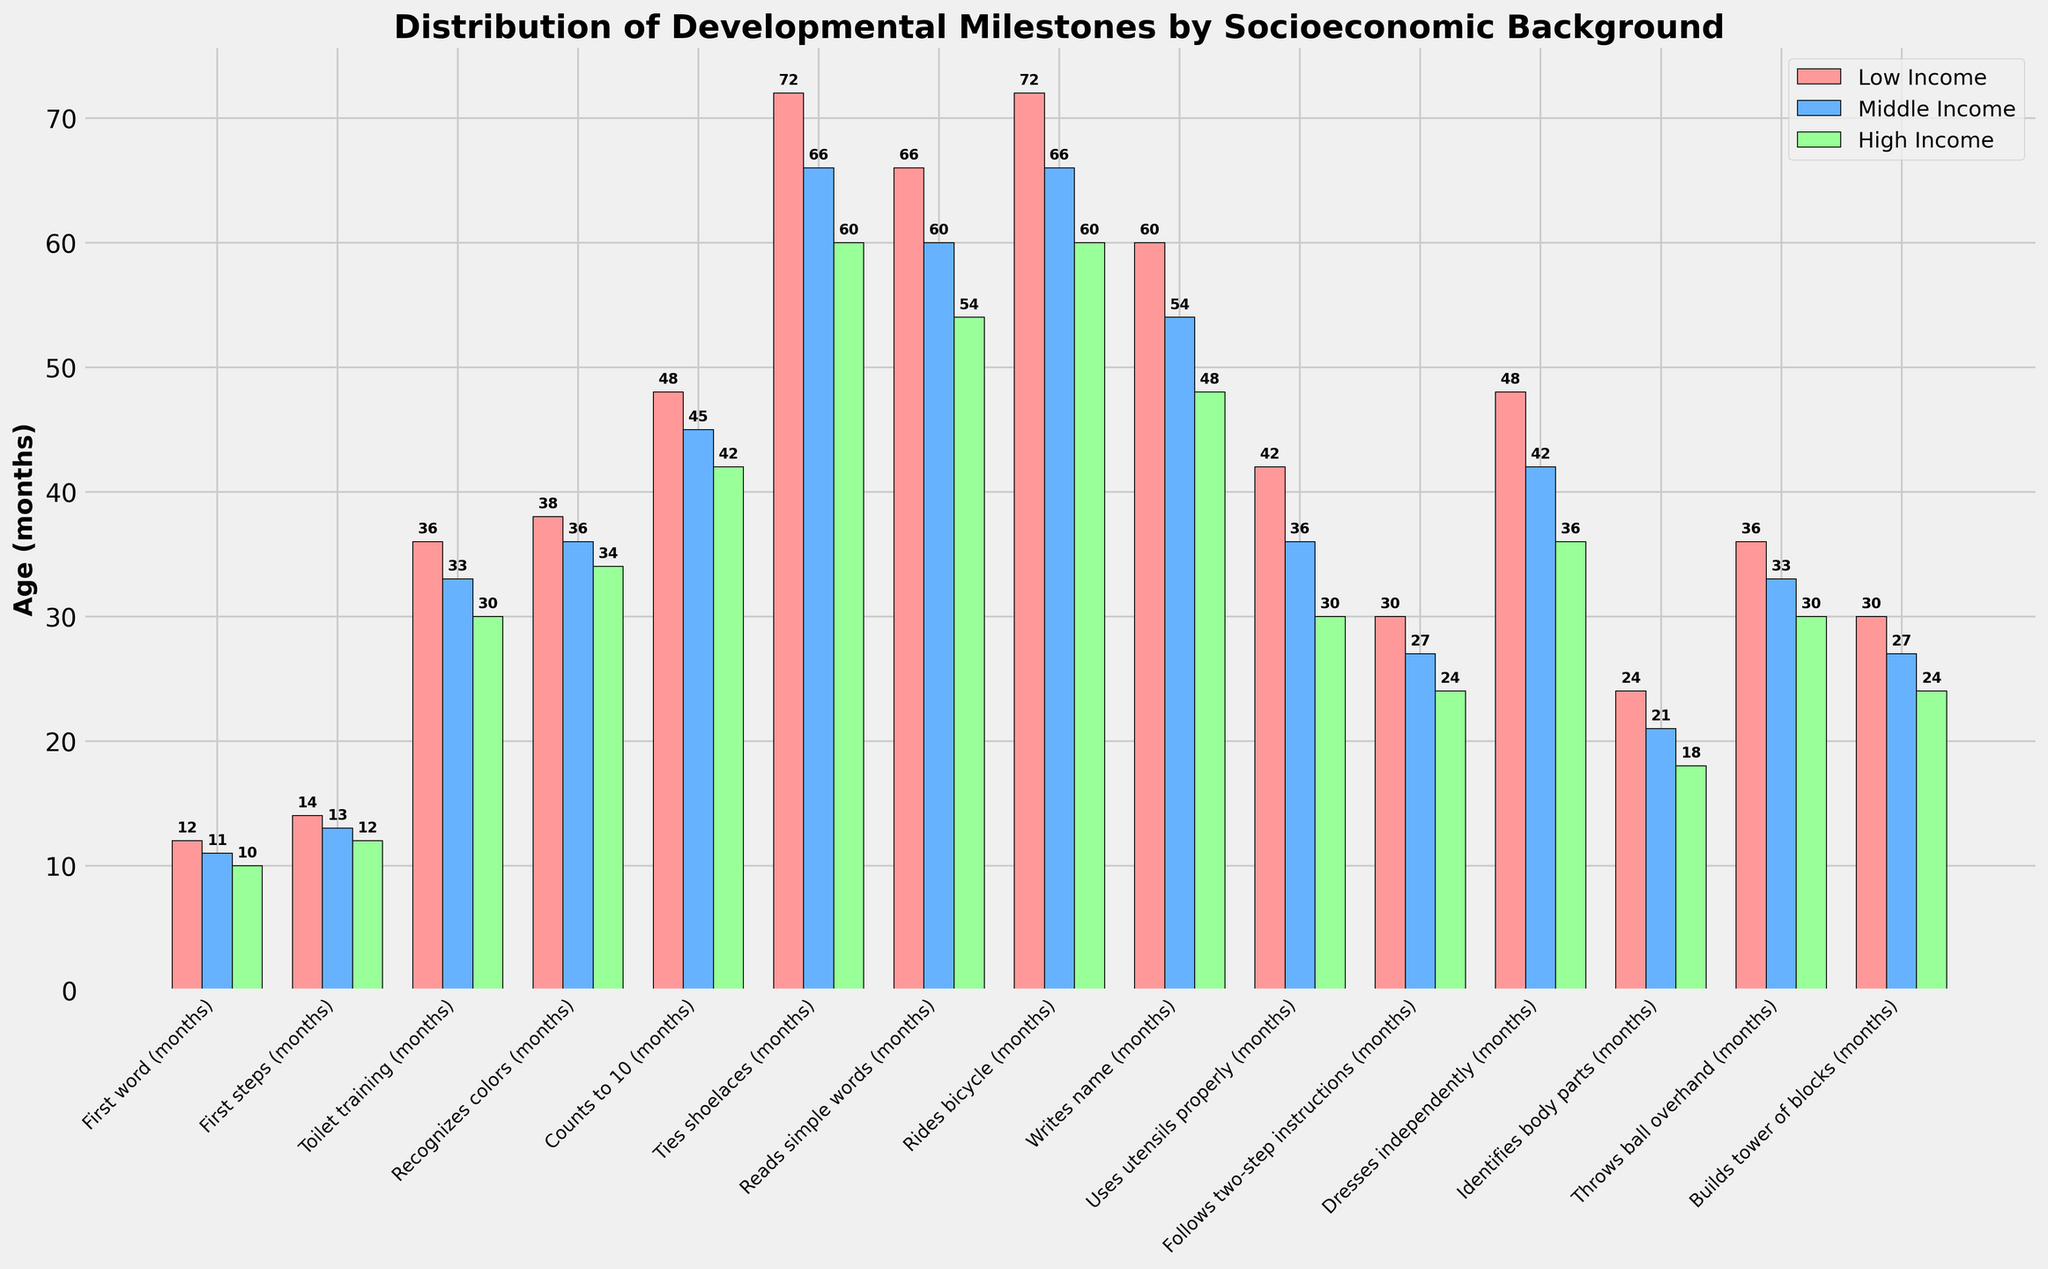Which socioeconomic group reaches the milestone "First word" the earliest? In the figure, each socioeconomic group is represented by a different color. For the milestone "First word," the group with the shortest bar (which means they achieve it in the fewest months) is the High Income group with 10 months.
Answer: High Income How many months apart are the milestones "Toilet training" and "Counts to 10" for the Low Income group? For the Low Income group, "Toilet training" is achieved at 36 months, and "Counts to 10" is achieved at 48 months. The difference between these two milestones is 48 - 36 = 12 months.
Answer: 12 months Which milestone has the largest discrepancy in achievement age between Low Income and High Income groups? By visually comparing the height of the bars, "Ties shoelaces" shows the largest difference between Low Income (72 months) and High Income (60 months) groups. The discrepancy is 72 - 60 = 12 months.
Answer: Ties shoelaces What is the average age of achieving the milestone "Writes name" across all socioeconomic groups? The milestone "Writes name" is achieved at 60 months for Low Income, 54 months for Middle Income, and 48 months for High Income. The average is (60 + 54 + 48) / 3 = 54 months.
Answer: 54 months Which group takes longer to achieve "Follows two-step instructions," and by how many months compared to the High Income group? For the milestone "Follows two-step instructions," the Low Income group takes 30 months, the Middle Income group takes 27 months, and the High Income group takes 24 months. The Low Income group takes the longest (30 months). The difference between Low Income and High Income is 30 - 24 = 6 months.
Answer: Low Income, 6 months Which milestones are achieved at the same age by both the Middle Income and High Income groups? By examining the bars, "Uses utensils properly" is achieved at 36 months by both the Middle Income and High Income groups.
Answer: Uses utensils properly Which socioeconomic group shows the least variation in age for achieving different milestones? By visually comparing the range of bar heights across all milestones, the High Income group shows the least variation as their bars span a smaller range of months (from 10 to 60 months).
Answer: High Income What is the total number of months required by the Middle Income group to achieve "Rides bicycle" and "Reads simple words"? The Middle Income group achieves "Rides bicycle" at 66 months and "Reads simple words" at 60 months. The total number of months is 66 + 60 = 126.
Answer: 126 months 